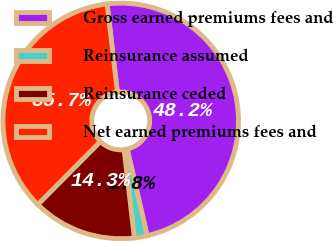Convert chart to OTSL. <chart><loc_0><loc_0><loc_500><loc_500><pie_chart><fcel>Gross earned premiums fees and<fcel>Reinsurance assumed<fcel>Reinsurance ceded<fcel>Net earned premiums fees and<nl><fcel>48.25%<fcel>1.75%<fcel>14.28%<fcel>35.72%<nl></chart> 